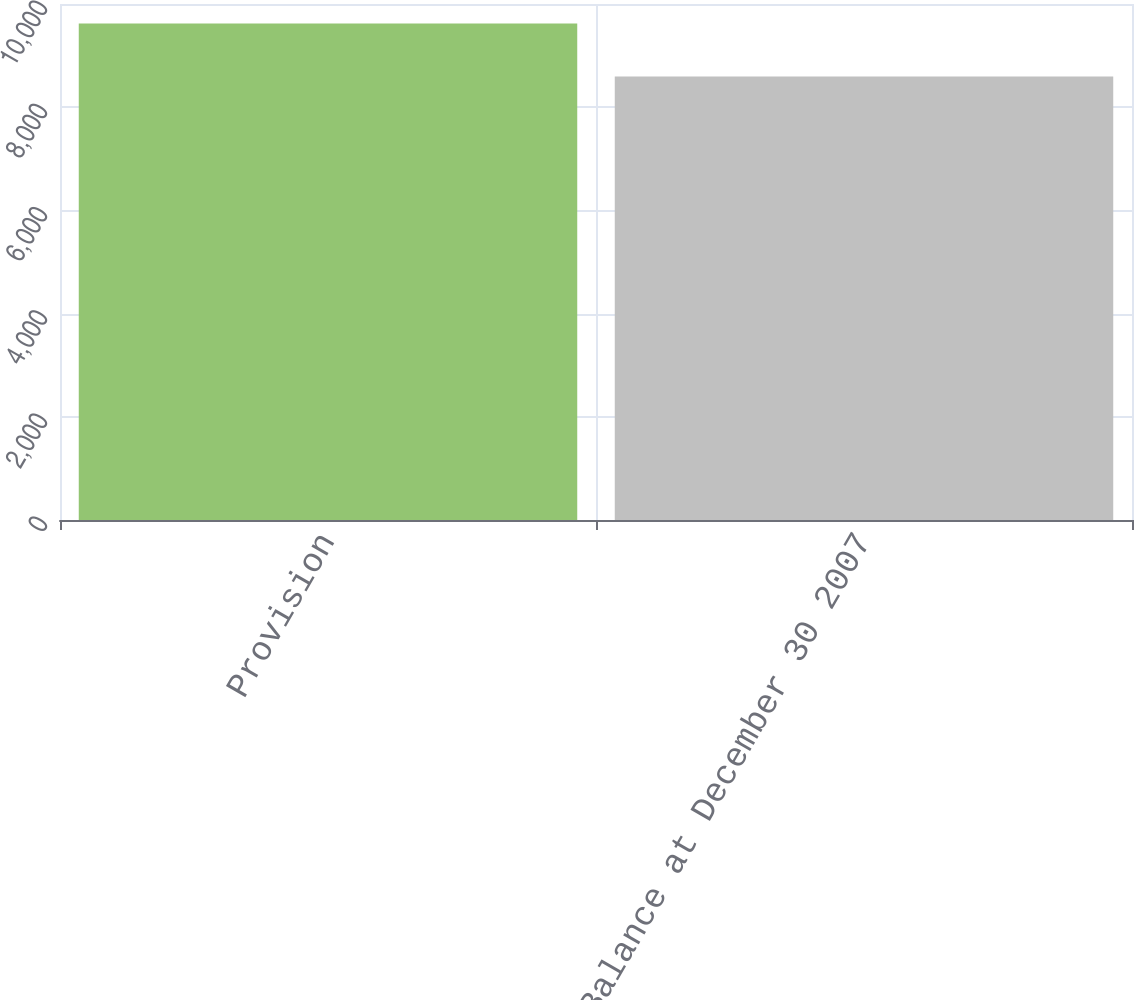Convert chart. <chart><loc_0><loc_0><loc_500><loc_500><bar_chart><fcel>Provision<fcel>Balance at December 30 2007<nl><fcel>9624<fcel>8596<nl></chart> 